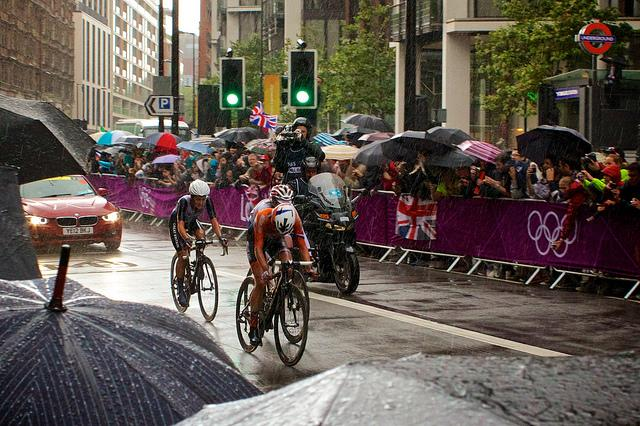When was the Union Jack invented? Please explain your reasoning. 1606. The union jack was invented in 1606. 